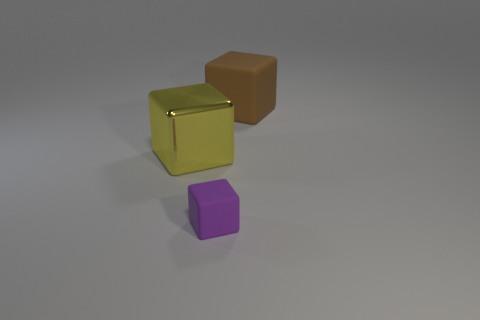What lighting conditions are present in the scene? The image depicts a neutral lighting environment with what appears to be a singular light source casting soft shadows. The direction of the shadows indicates the light source is positioned above the objects, with a slight bias towards the right side of the frame. 